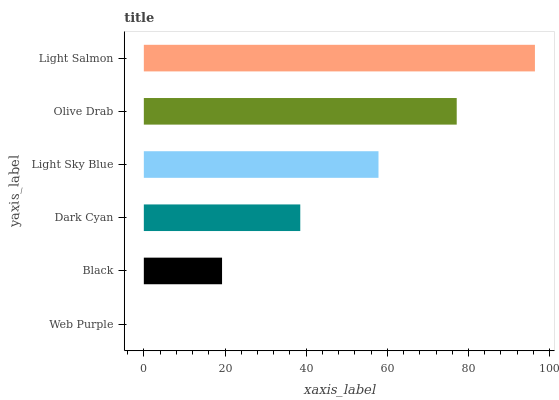Is Web Purple the minimum?
Answer yes or no. Yes. Is Light Salmon the maximum?
Answer yes or no. Yes. Is Black the minimum?
Answer yes or no. No. Is Black the maximum?
Answer yes or no. No. Is Black greater than Web Purple?
Answer yes or no. Yes. Is Web Purple less than Black?
Answer yes or no. Yes. Is Web Purple greater than Black?
Answer yes or no. No. Is Black less than Web Purple?
Answer yes or no. No. Is Light Sky Blue the high median?
Answer yes or no. Yes. Is Dark Cyan the low median?
Answer yes or no. Yes. Is Dark Cyan the high median?
Answer yes or no. No. Is Light Sky Blue the low median?
Answer yes or no. No. 